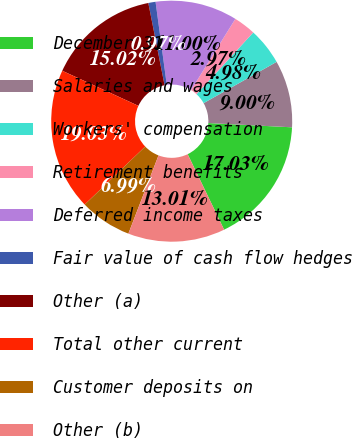<chart> <loc_0><loc_0><loc_500><loc_500><pie_chart><fcel>December 31<fcel>Salaries and wages<fcel>Workers' compensation<fcel>Retirement benefits<fcel>Deferred income taxes<fcel>Fair value of cash flow hedges<fcel>Other (a)<fcel>Total other current<fcel>Customer deposits on<fcel>Other (b)<nl><fcel>17.03%<fcel>9.0%<fcel>4.98%<fcel>2.97%<fcel>11.0%<fcel>0.97%<fcel>15.02%<fcel>19.03%<fcel>6.99%<fcel>13.01%<nl></chart> 